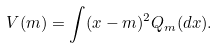Convert formula to latex. <formula><loc_0><loc_0><loc_500><loc_500>V ( m ) = \int ( x - m ) ^ { 2 } Q _ { m } ( d x ) .</formula> 